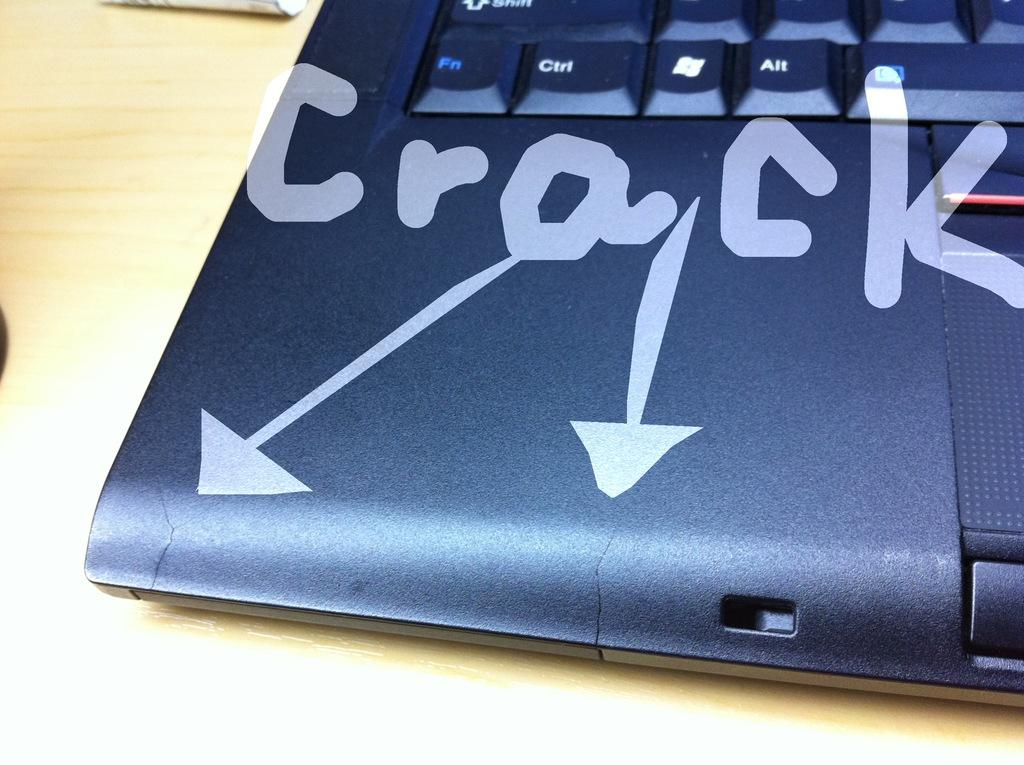<image>
Describe the image concisely. An image of a computer keyboard with cracks that are being identified on the photo. 